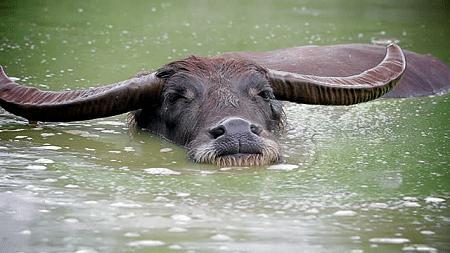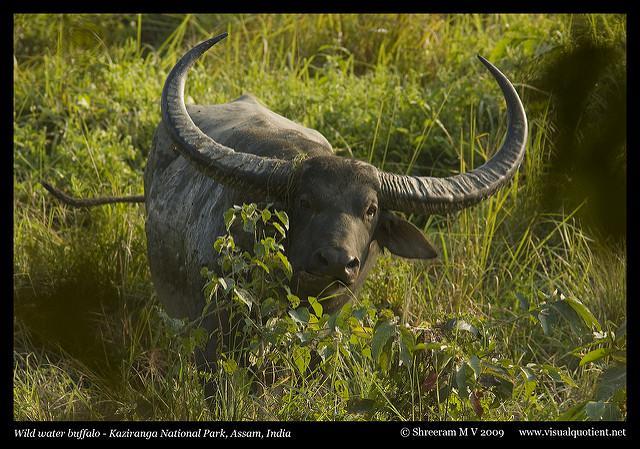The first image is the image on the left, the second image is the image on the right. Assess this claim about the two images: "a water buffalo is up to it's neck in water". Correct or not? Answer yes or no. Yes. The first image is the image on the left, the second image is the image on the right. For the images displayed, is the sentence "There is a total of 1 buffalo in water up to their head." factually correct? Answer yes or no. Yes. 